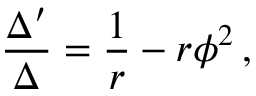Convert formula to latex. <formula><loc_0><loc_0><loc_500><loc_500>\frac { \Delta ^ { \prime } } { \Delta } = \frac { 1 } { r } - r \phi ^ { 2 } \, ,</formula> 